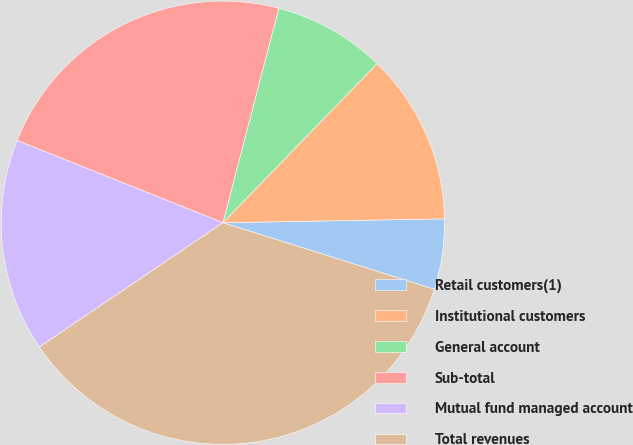Convert chart to OTSL. <chart><loc_0><loc_0><loc_500><loc_500><pie_chart><fcel>Retail customers(1)<fcel>Institutional customers<fcel>General account<fcel>Sub-total<fcel>Mutual fund managed account<fcel>Total revenues<nl><fcel>5.13%<fcel>12.47%<fcel>8.19%<fcel>23.01%<fcel>15.53%<fcel>35.67%<nl></chart> 